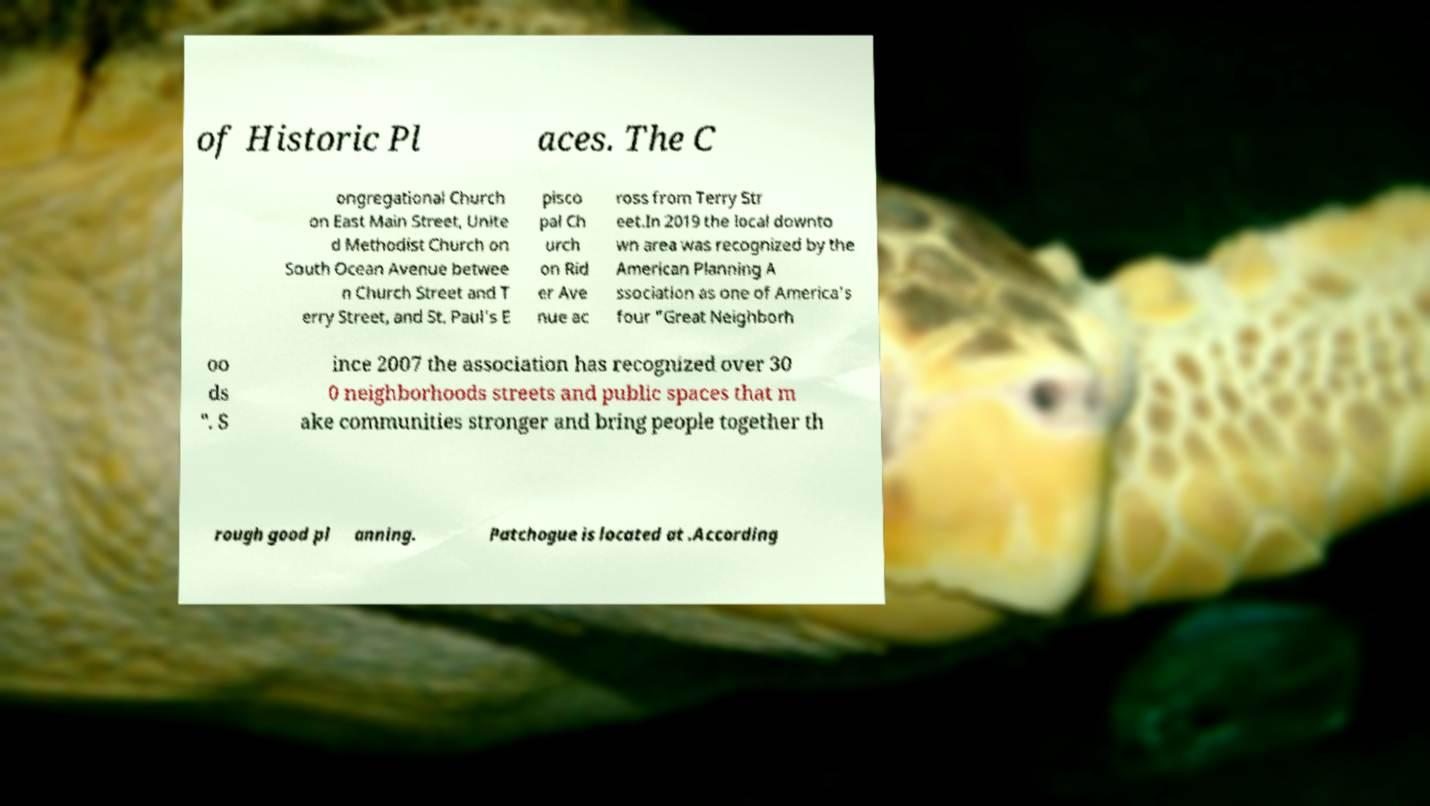Can you accurately transcribe the text from the provided image for me? of Historic Pl aces. The C ongregational Church on East Main Street, Unite d Methodist Church on South Ocean Avenue betwee n Church Street and T erry Street, and St. Paul's E pisco pal Ch urch on Rid er Ave nue ac ross from Terry Str eet.In 2019 the local downto wn area was recognized by the American Planning A ssociation as one of America's four "Great Neighborh oo ds ". S ince 2007 the association has recognized over 30 0 neighborhoods streets and public spaces that m ake communities stronger and bring people together th rough good pl anning. Patchogue is located at .According 